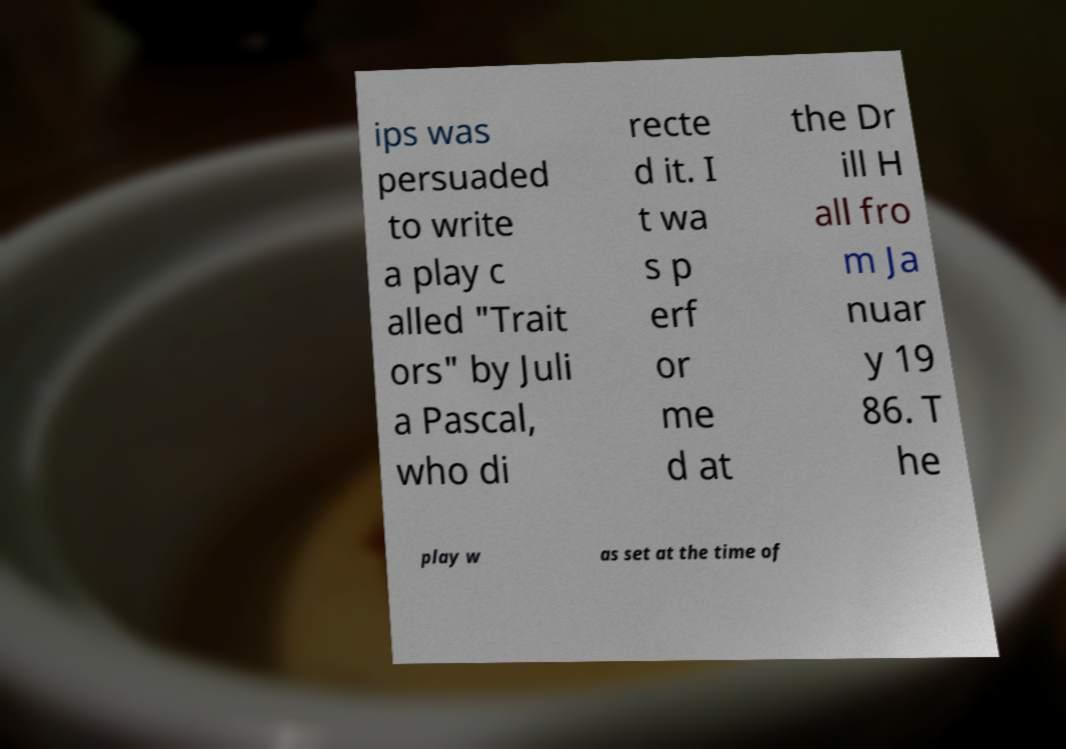Could you extract and type out the text from this image? ips was persuaded to write a play c alled "Trait ors" by Juli a Pascal, who di recte d it. I t wa s p erf or me d at the Dr ill H all fro m Ja nuar y 19 86. T he play w as set at the time of 